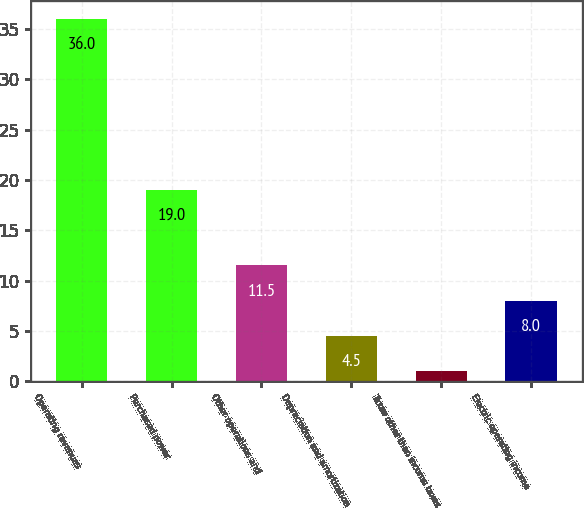Convert chart to OTSL. <chart><loc_0><loc_0><loc_500><loc_500><bar_chart><fcel>Operating revenues<fcel>Purchased power<fcel>Other operations and<fcel>Depreciation and amortization<fcel>Taxes other than income taxes<fcel>Electric operating income<nl><fcel>36<fcel>19<fcel>11.5<fcel>4.5<fcel>1<fcel>8<nl></chart> 